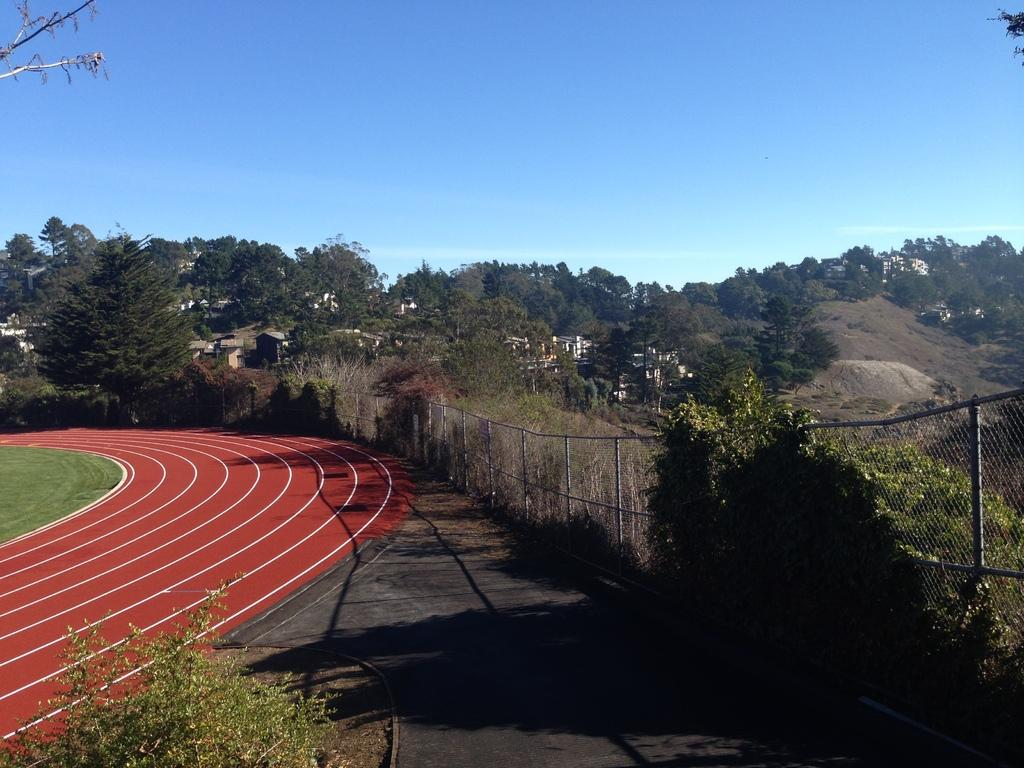What type of natural elements can be seen in the image? There are trees and grass visible in the image. What type of man-made structures can be seen in the image? There are buildings and fencing visible in the image. What is the terrain like in the image? There is a hill in the image, indicating a varied landscape. What part of the natural environment is visible in the image? The ground and sky are visible in the image. What is the opinion of the board about the need for more trees in the image? There is no board or any indication of opinions present in the image. The image simply shows trees, buildings, fencing, a hill, the ground, grass, and the sky. 